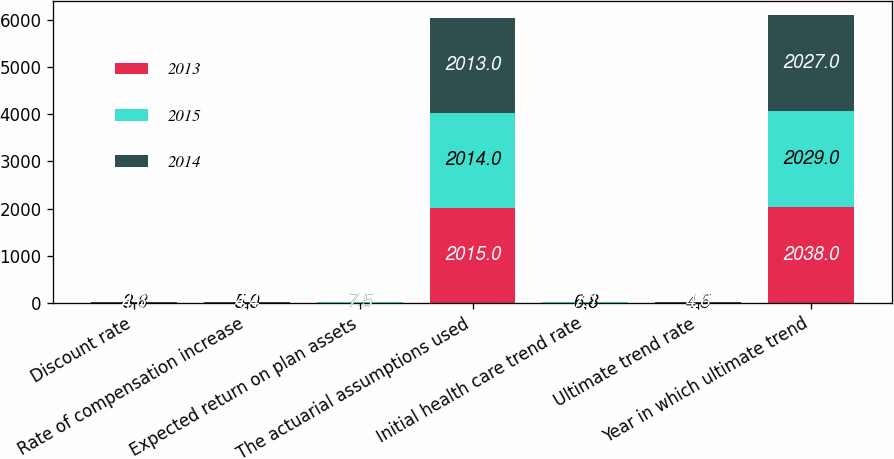Convert chart to OTSL. <chart><loc_0><loc_0><loc_500><loc_500><stacked_bar_chart><ecel><fcel>Discount rate<fcel>Rate of compensation increase<fcel>Expected return on plan assets<fcel>The actuarial assumptions used<fcel>Initial health care trend rate<fcel>Ultimate trend rate<fcel>Year in which ultimate trend<nl><fcel>2013<fcel>4.1<fcel>4.5<fcel>7.5<fcel>2015<fcel>6.7<fcel>4.5<fcel>2038<nl><fcel>2015<fcel>3.8<fcel>5<fcel>7.5<fcel>2014<fcel>6.8<fcel>4.5<fcel>2029<nl><fcel>2014<fcel>4.6<fcel>4.4<fcel>7.5<fcel>2013<fcel>7.1<fcel>4.6<fcel>2027<nl></chart> 